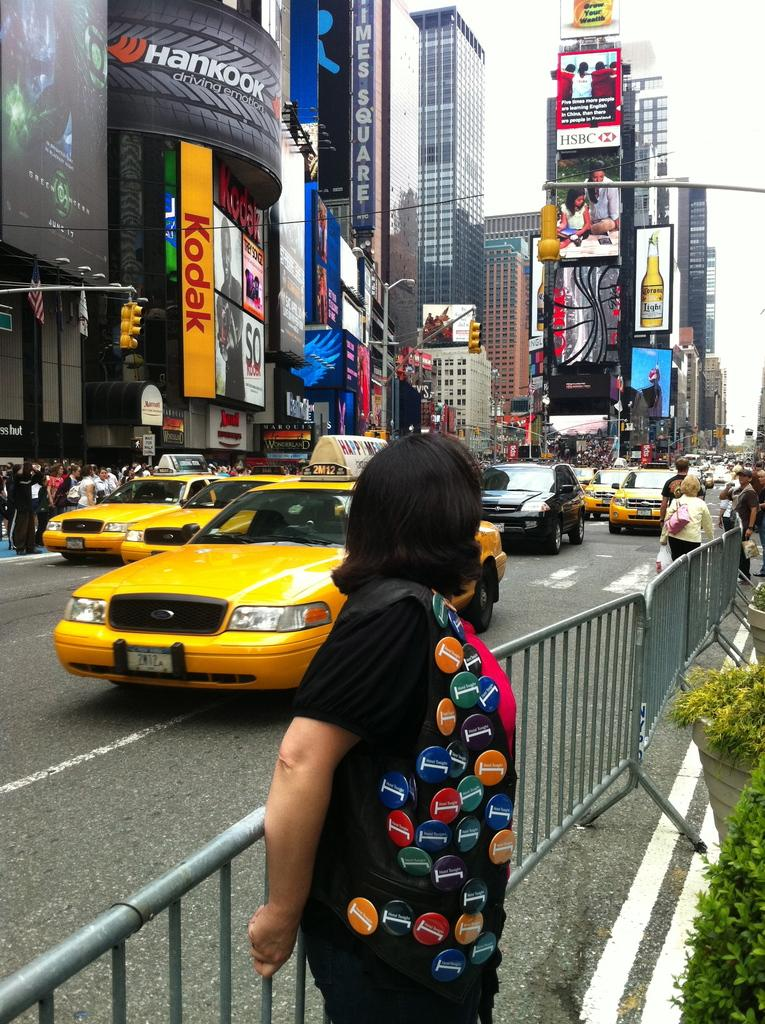<image>
Write a terse but informative summary of the picture. A woman with pins on her vest is standing by a street full of taxis under a Kodak sign. 